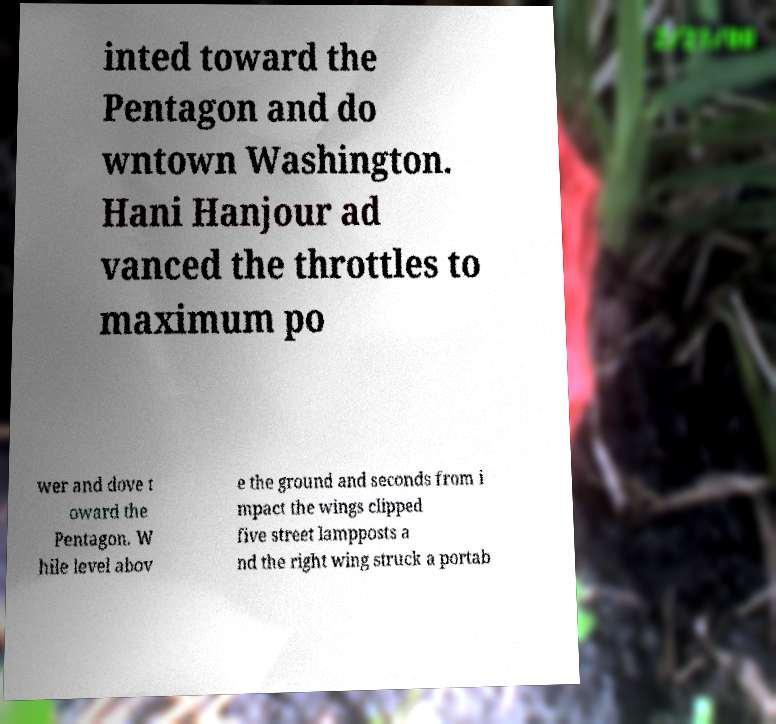What messages or text are displayed in this image? I need them in a readable, typed format. inted toward the Pentagon and do wntown Washington. Hani Hanjour ad vanced the throttles to maximum po wer and dove t oward the Pentagon. W hile level abov e the ground and seconds from i mpact the wings clipped five street lampposts a nd the right wing struck a portab 